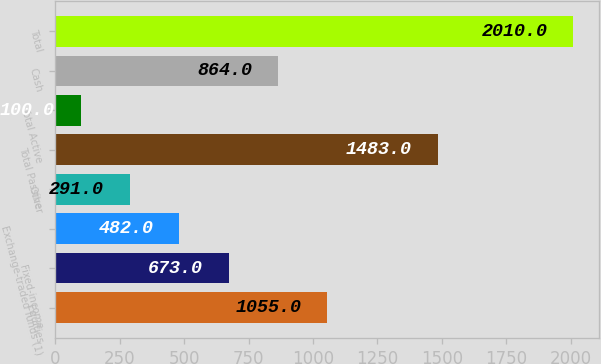<chart> <loc_0><loc_0><loc_500><loc_500><bar_chart><fcel>Equities<fcel>Fixed-income<fcel>Exchange-traded funds (1)<fcel>Other<fcel>Total Passive<fcel>Total Active<fcel>Cash<fcel>Total<nl><fcel>1055<fcel>673<fcel>482<fcel>291<fcel>1483<fcel>100<fcel>864<fcel>2010<nl></chart> 